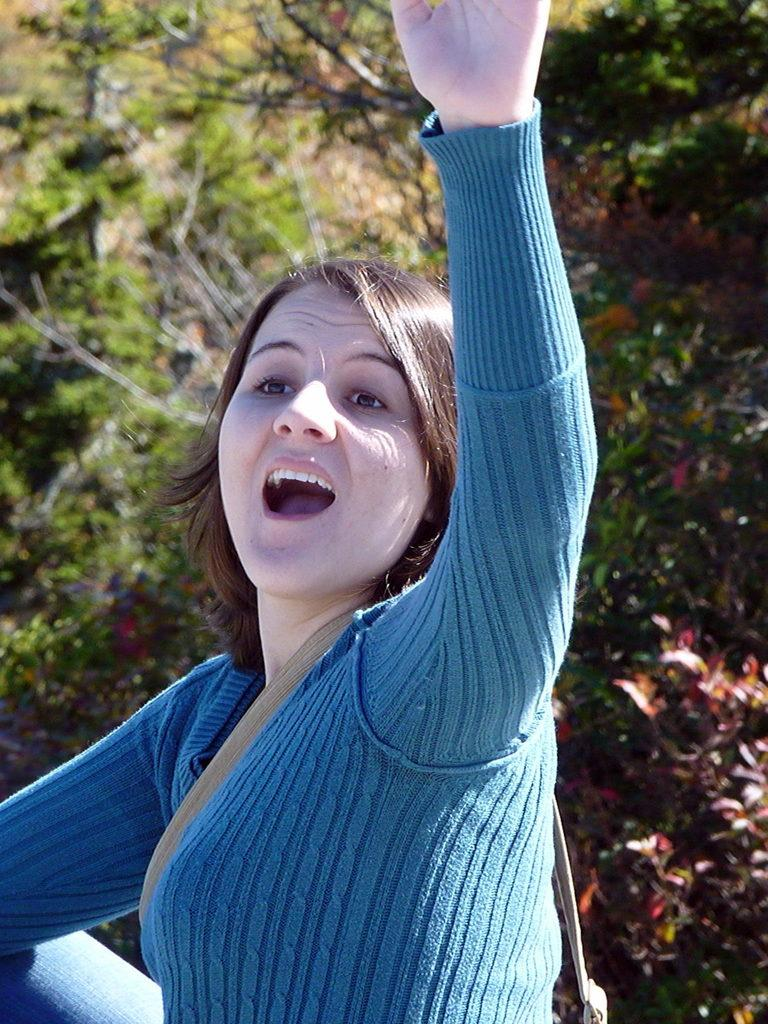Who is present in the image? There is a woman in the image. What is the woman wearing? The woman is wearing a blue dress. What can be seen in the background of the image? There are trees in the background of the image. What type of print can be seen on the woman's dress in the image? There is no print visible on the woman's dress in the image; it is a solid blue color. What type of machine is being used by the woman in the image? There is no machine present in the image, and the woman is not using any machine. 